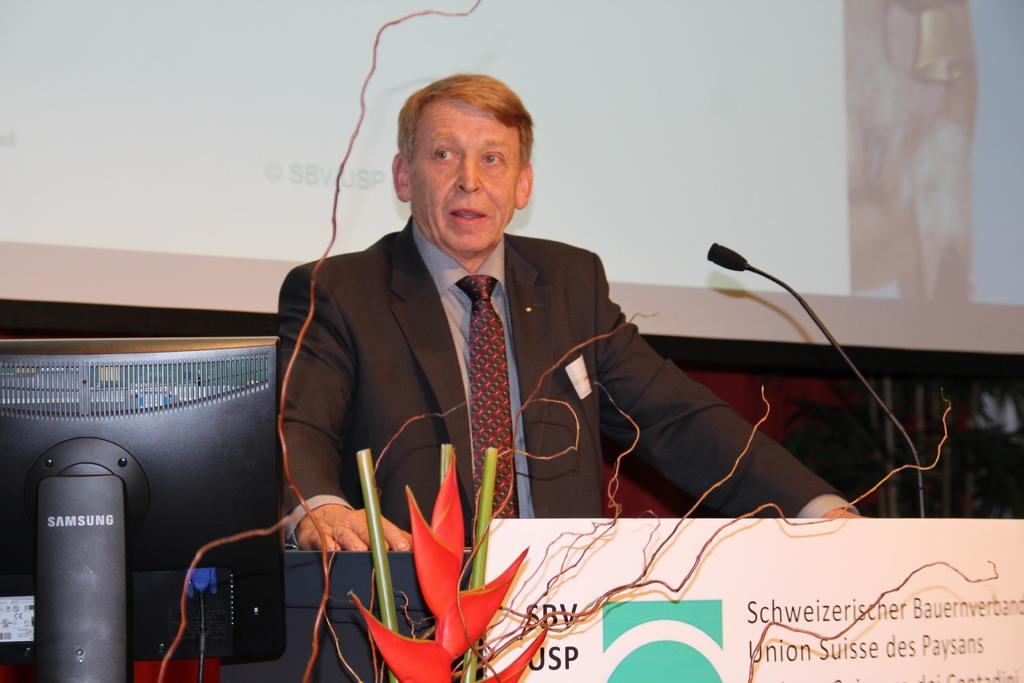What is the man in the image doing? The man is speaking in the microphone. What type of clothing is the man wearing on his upper body? The man is wearing a coat, a tie, and a shirt. How does the man maintain a quiet environment while speaking in the microphone? The image does not provide information about the man maintaining a quiet environment, as it only shows him speaking into a microphone. 